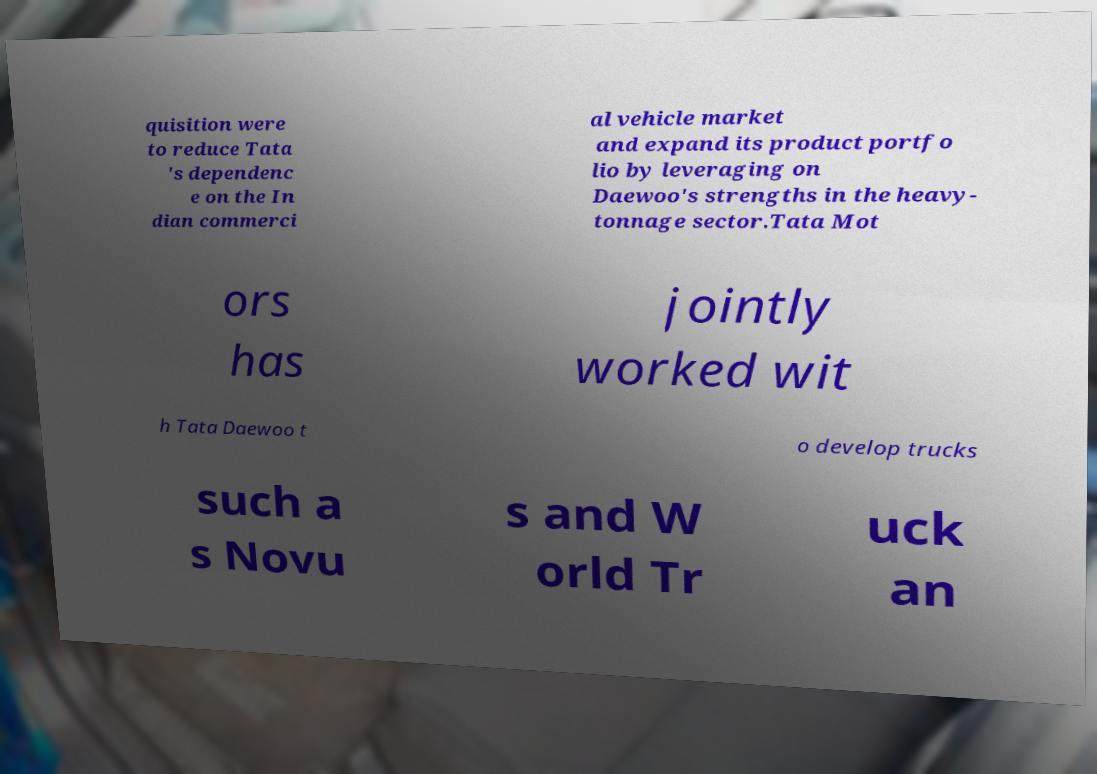What messages or text are displayed in this image? I need them in a readable, typed format. quisition were to reduce Tata 's dependenc e on the In dian commerci al vehicle market and expand its product portfo lio by leveraging on Daewoo's strengths in the heavy- tonnage sector.Tata Mot ors has jointly worked wit h Tata Daewoo t o develop trucks such a s Novu s and W orld Tr uck an 